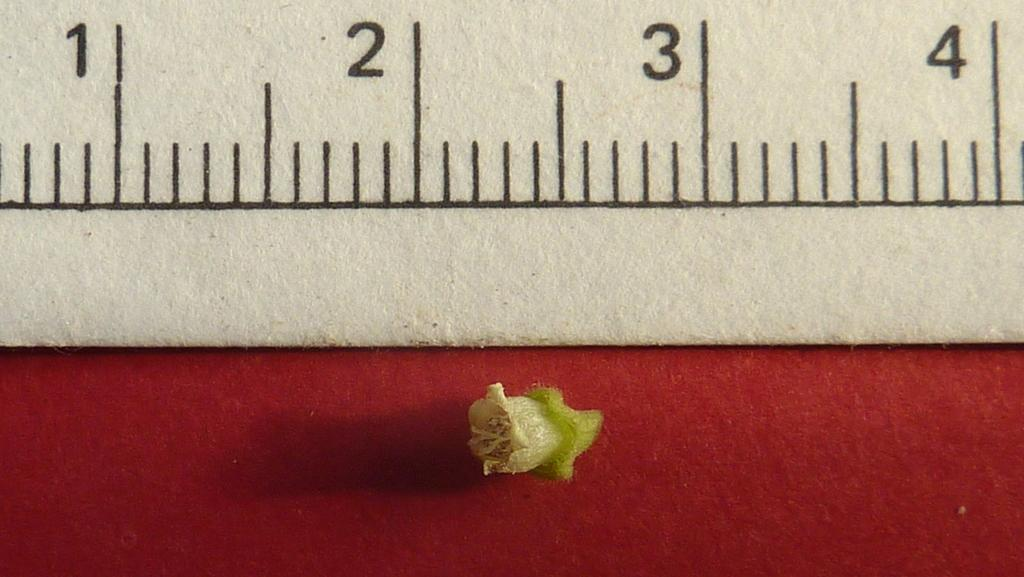<image>
Summarize the visual content of the image. A very small seed sits under a ruler with the 1, 2, 3, 4 inche marks noted at the top. 